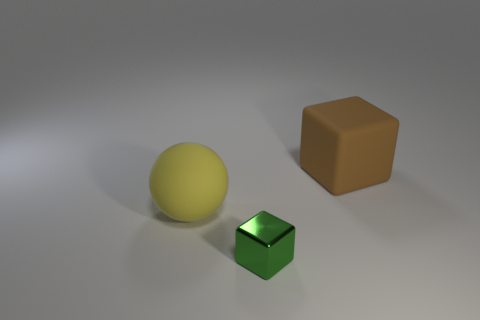There is a block that is to the left of the brown thing; is its size the same as the matte object that is behind the large yellow object?
Provide a succinct answer. No. How many tiny objects are either metal blocks or balls?
Provide a succinct answer. 1. What number of objects are both to the right of the big rubber ball and in front of the brown cube?
Provide a succinct answer. 1. Do the big brown cube and the large object that is on the left side of the large brown cube have the same material?
Ensure brevity in your answer.  Yes. What number of green objects are large matte spheres or large objects?
Your response must be concise. 0. Is there another brown block of the same size as the brown block?
Make the answer very short. No. What is the material of the thing that is to the left of the cube on the left side of the large rubber object right of the small shiny block?
Your answer should be very brief. Rubber. Are there the same number of yellow matte objects that are on the left side of the tiny green object and matte cubes?
Ensure brevity in your answer.  Yes. Does the cube that is behind the small green metal cube have the same material as the thing in front of the big yellow rubber object?
Your response must be concise. No. What number of things are tiny things or large matte objects on the right side of the sphere?
Your answer should be compact. 2. 